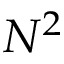<formula> <loc_0><loc_0><loc_500><loc_500>N ^ { 2 }</formula> 